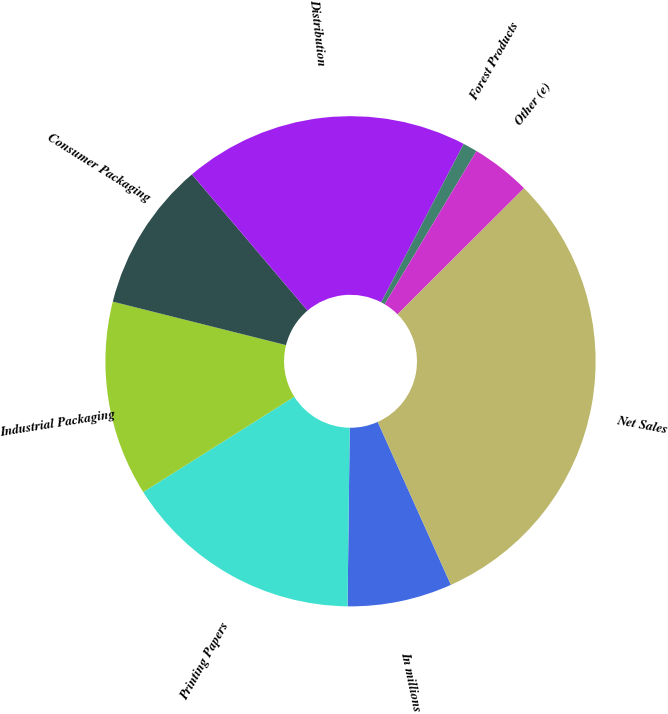<chart> <loc_0><loc_0><loc_500><loc_500><pie_chart><fcel>In millions<fcel>Printing Papers<fcel>Industrial Packaging<fcel>Consumer Packaging<fcel>Distribution<fcel>Forest Products<fcel>Other (e)<fcel>Net Sales<nl><fcel>6.91%<fcel>15.85%<fcel>12.87%<fcel>9.89%<fcel>18.84%<fcel>0.95%<fcel>3.93%<fcel>30.76%<nl></chart> 